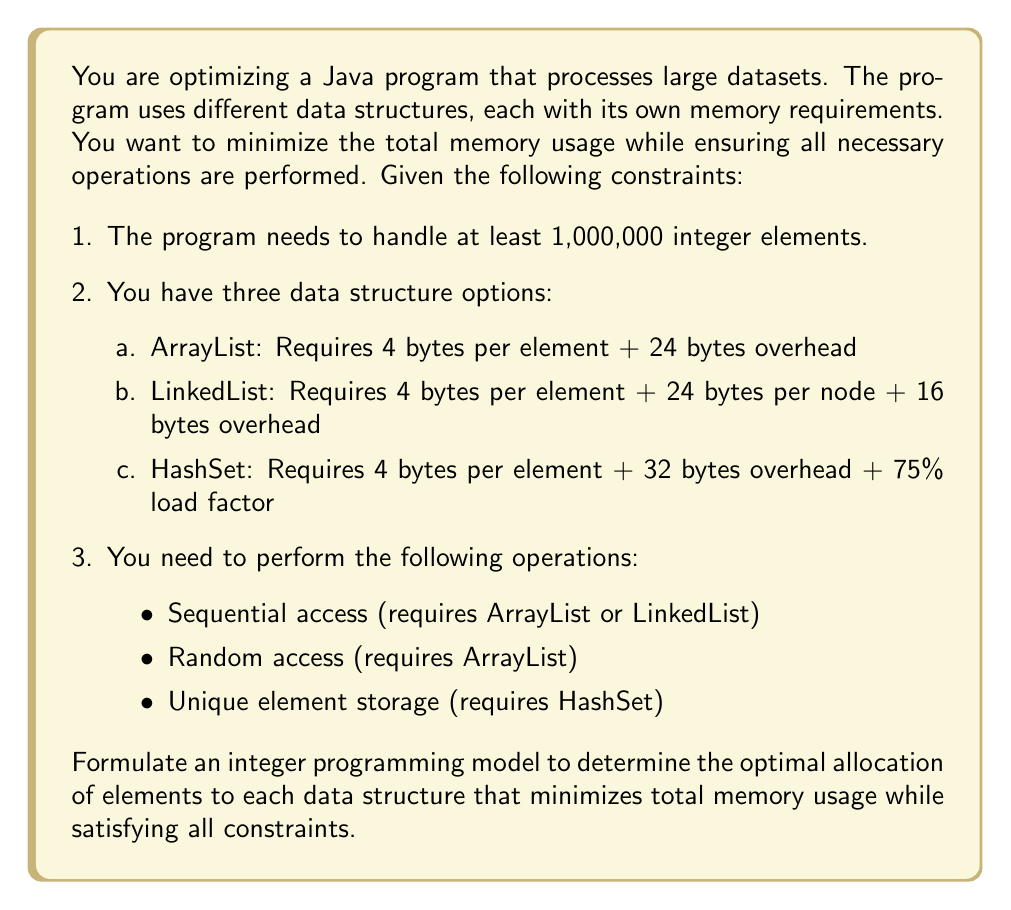Teach me how to tackle this problem. Let's approach this step-by-step:

1. Define decision variables:
   $x_1$ = number of elements in ArrayList
   $x_2$ = number of elements in LinkedList
   $x_3$ = number of elements in HashSet

2. Objective function:
   Minimize total memory usage:
   $$\text{Minimize } Z = (4x_1 + 24) + (28x_2 + 16) + (4x_3 + 32 + \frac{4x_3}{0.75})$$

   Simplifying the HashSet term:
   $$\text{Minimize } Z = 4x_1 + 28x_2 + \frac{16x_3}{3} + 72$$

3. Constraints:
   a. Total elements constraint:
      $$x_1 + x_2 + x_3 \geq 1,000,000$$

   b. Sequential access constraint (ArrayList or LinkedList):
      $$x_1 + x_2 \geq 1$$

   c. Random access constraint (ArrayList):
      $$x_1 \geq 1$$

   d. Unique element storage constraint (HashSet):
      $$x_3 \geq 1$$

   e. Non-negativity and integer constraints:
      $$x_1, x_2, x_3 \geq 0 \text{ and integer}$$

4. Final integer programming model:

   $$\begin{align*}
   \text{Minimize } Z &= 4x_1 + 28x_2 + \frac{16x_3}{3} + 72 \\
   \text{Subject to:} \\
   x_1 + x_2 + x_3 &\geq 1,000,000 \\
   x_1 + x_2 &\geq 1 \\
   x_1 &\geq 1 \\
   x_3 &\geq 1 \\
   x_1, x_2, x_3 &\geq 0 \text{ and integer}
   \end{align*}$$

This model can be solved using integer programming techniques to find the optimal allocation of elements to each data structure, minimizing total memory usage while satisfying all operational requirements.
Answer: The integer programming model to minimize memory usage in the Java program is:

$$\begin{align*}
\text{Minimize } Z &= 4x_1 + 28x_2 + \frac{16x_3}{3} + 72 \\
\text{Subject to:} \\
x_1 + x_2 + x_3 &\geq 1,000,000 \\
x_1 + x_2 &\geq 1 \\
x_1 &\geq 1 \\
x_3 &\geq 1 \\
x_1, x_2, x_3 &\geq 0 \text{ and integer}
\end{align*}$$

Where $x_1$, $x_2$, and $x_3$ represent the number of elements in ArrayList, LinkedList, and HashSet, respectively. 